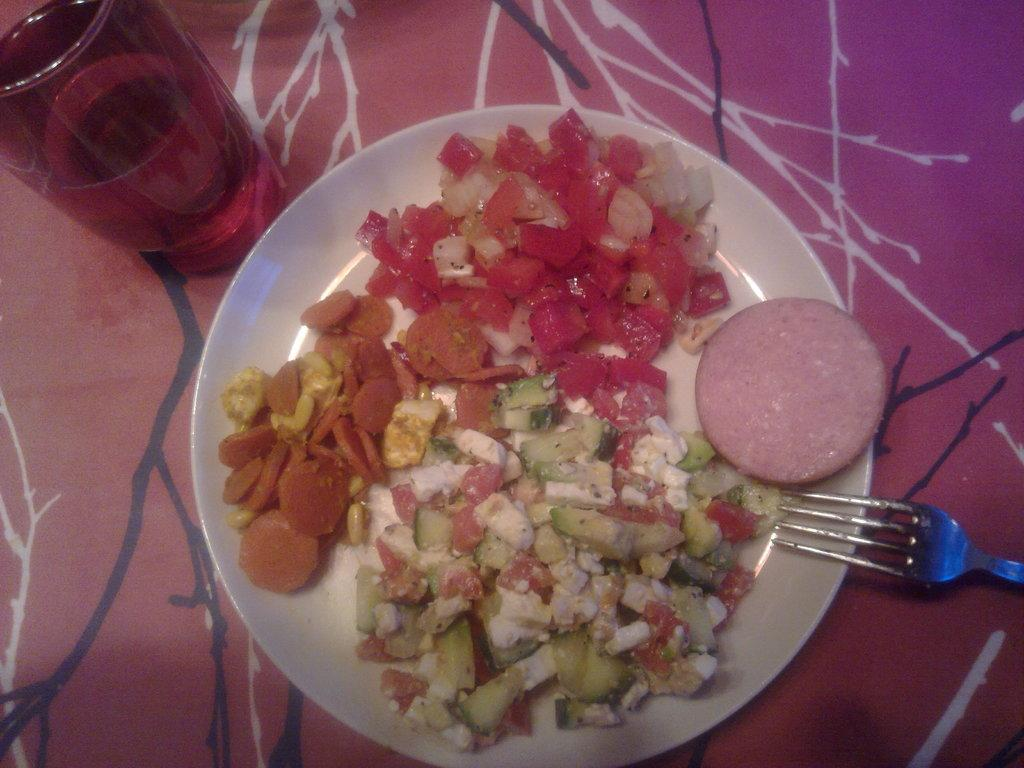What is on the plate in the image? There is food on a plate in the image. What utensil is on the plate? There is a fork on the plate. Where is the plate located? The plate is on a table. What is covering the table? The table is covered with a cloth. What else can be seen on the table? There is a glass filled with a drink on the table. What type of bear can be seen interacting with the rice on the table? There is no bear or rice present in the image. 